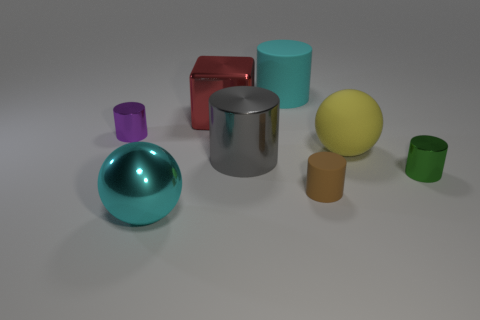Add 1 large cyan things. How many objects exist? 9 Subtract all shiny cylinders. How many cylinders are left? 2 Subtract 1 yellow spheres. How many objects are left? 7 Subtract all blocks. How many objects are left? 7 Subtract 1 spheres. How many spheres are left? 1 Subtract all blue balls. Subtract all gray blocks. How many balls are left? 2 Subtract all brown cylinders. How many green spheres are left? 0 Subtract all big metal objects. Subtract all red cubes. How many objects are left? 4 Add 7 tiny purple objects. How many tiny purple objects are left? 8 Add 3 big gray cylinders. How many big gray cylinders exist? 4 